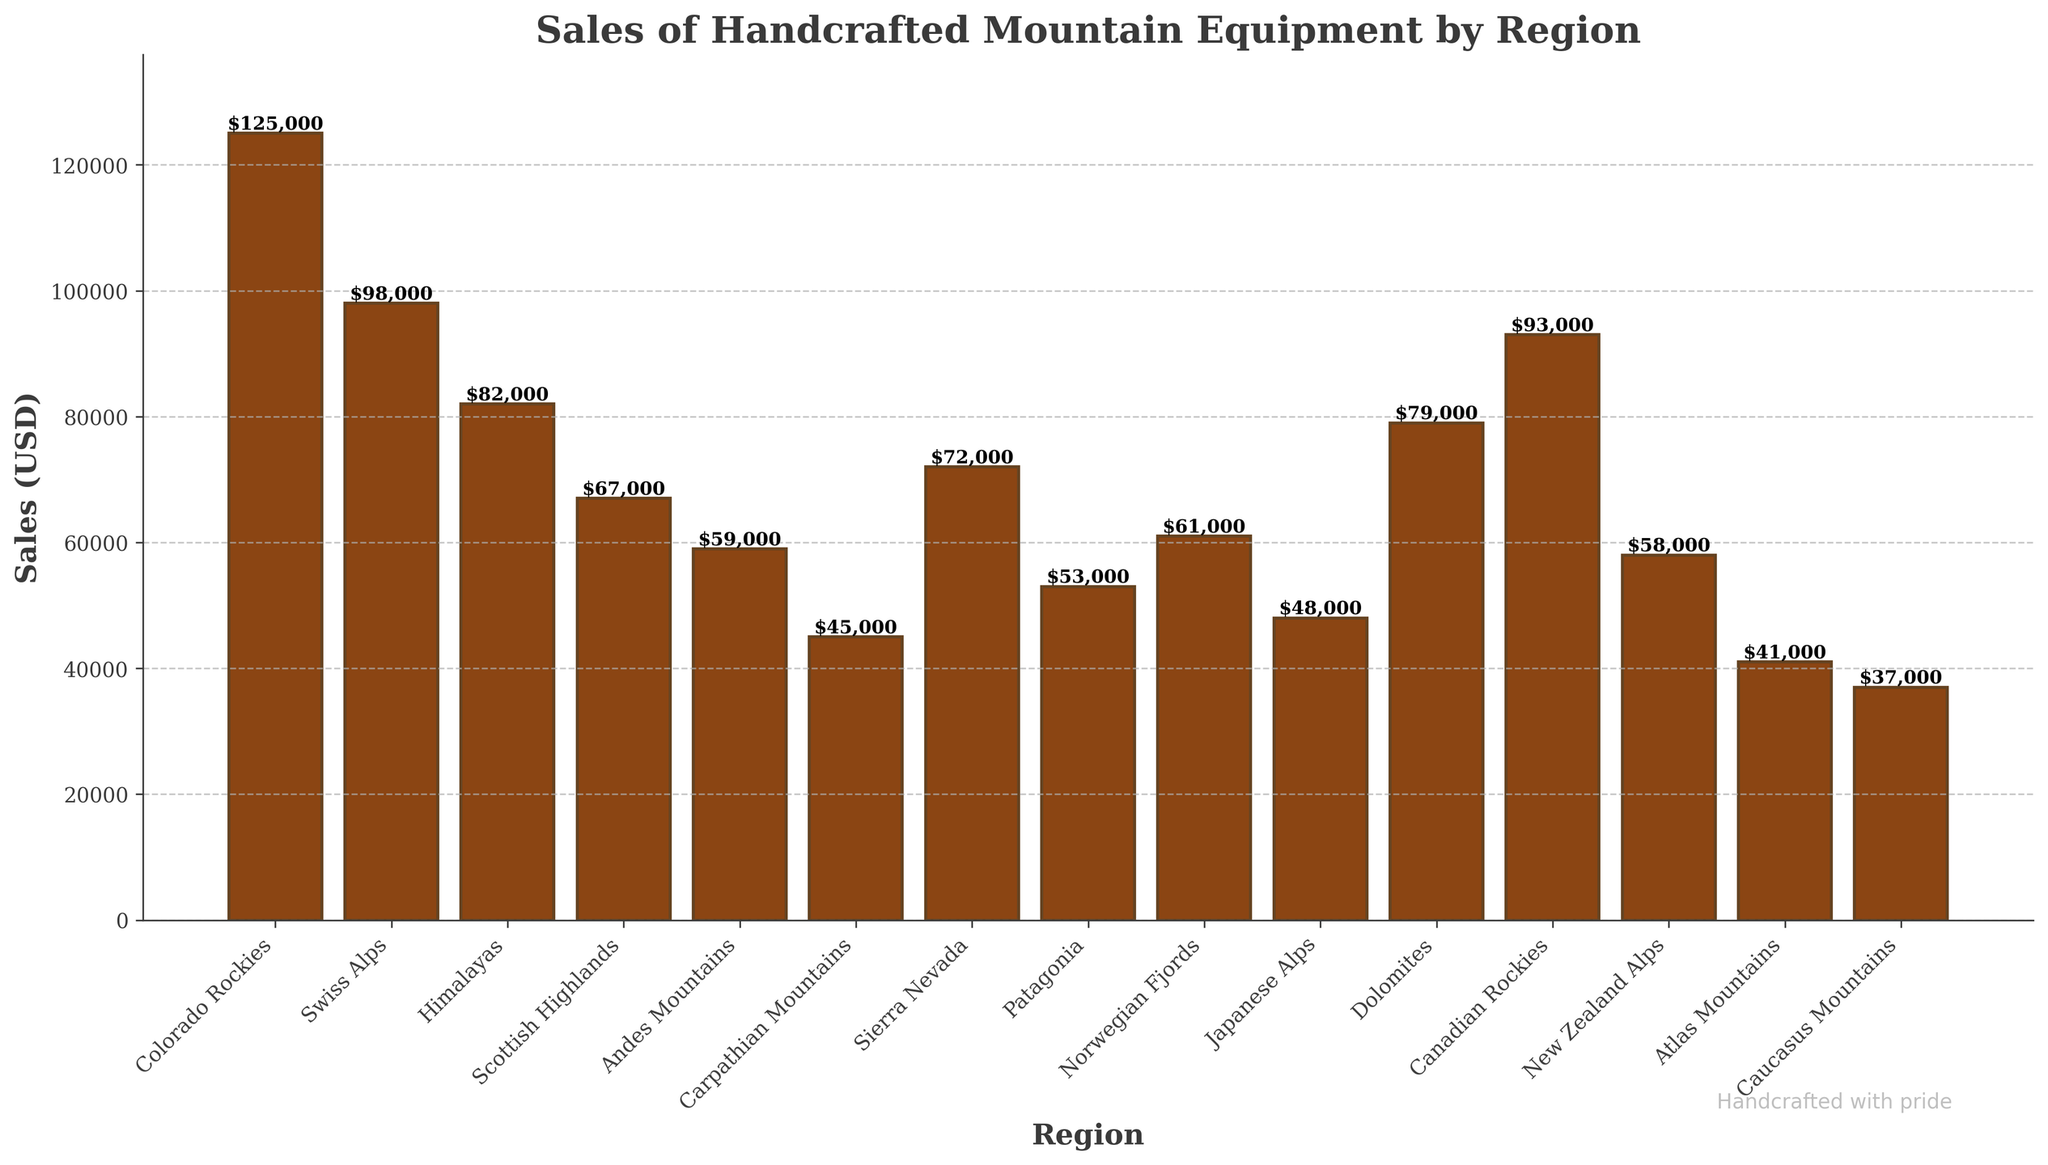Which region has the highest sales? Checking the highest bar in the figure, we see that the Colorado Rockies has the highest sales.
Answer: Colorado Rockies Which region has the lowest sales? Checking the lowest bar in the figure, we see that the Caucasus Mountains have the lowest sales.
Answer: Caucasus Mountains What is the difference in sales between the Colorado Rockies and the Scottish Highlands? The sales in the Colorado Rockies are $125,000 and in the Scottish Highlands are $67,000. The difference is $125,000 - $67,000 = $58,000.
Answer: $58,000 List the regions with sales over $80,000. By observing the bars higher than $80,000 in the chart, the regions are Colorado Rockies, Swiss Alps, Himalayas, and Canadian Rockies.
Answer: Colorado Rockies, Swiss Alps, Himalayas, Canadian Rockies What is the combined sales of the Swiss Alps and the Himalayas? The sales in the Swiss Alps are $98,000 and in the Himalayas are $82,000. The combined sales are $98,000 + $82,000 = $180,000.
Answer: $180,000 Which has higher sales, the Sierra Nevada or Pattagonia? Comparing the bars for Sierra Nevada and Patagonia, Sierra Nevada has higher sales with $72,000 compared to Patagonia's $53,000.
Answer: Sierra Nevada What is the average sales value across all regions? Add up all sales: $125,000 + $98,000 + $82,000 + $67,000 + $59,000 + $45,000 + $72,000 + $53,000 + $61,000 + $48,000 + $79,000 + $93,000 + $58,000 + $41,000 + $37,000 = $1,010,000. There are 15 regions, so the average is $1,010,000 / 15 = $67,333.33.
Answer: $67,333.33 Which region has sales closest to the average? The average sales are $67,333.33. Comparing this to each region's sales, the Scottish Highlands have sales of $67,000, which is closest to the average.
Answer: Scottish Highlands Compare the sales of the Dolomites and the Andes Mountains? The sales of the Dolomites are $79,000, whereas the Andes Mountains have sales of $59,000. The Dolomites have higher sales.
Answer: Dolomites What is the median sales value across all regions? The sales in ascending order are:
$37,000, $41,000, $45,000, $48,000, $53,000, $58,000, $59,000, $61,000, $67,000, $72,000, $79,000, $82,000, $93,000, $98,000, $125,000. The median sales (8th value in the ordered list) is $61,000.
Answer: $61,000 